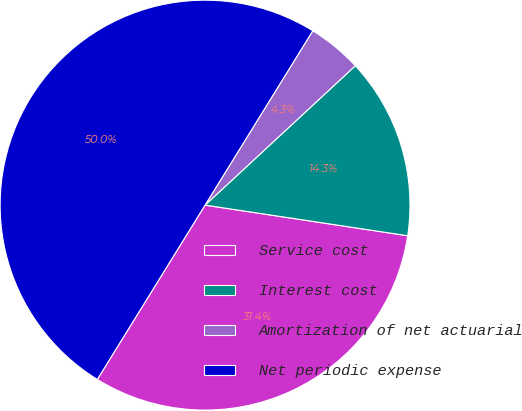Convert chart to OTSL. <chart><loc_0><loc_0><loc_500><loc_500><pie_chart><fcel>Service cost<fcel>Interest cost<fcel>Amortization of net actuarial<fcel>Net periodic expense<nl><fcel>31.43%<fcel>14.29%<fcel>4.29%<fcel>50.0%<nl></chart> 